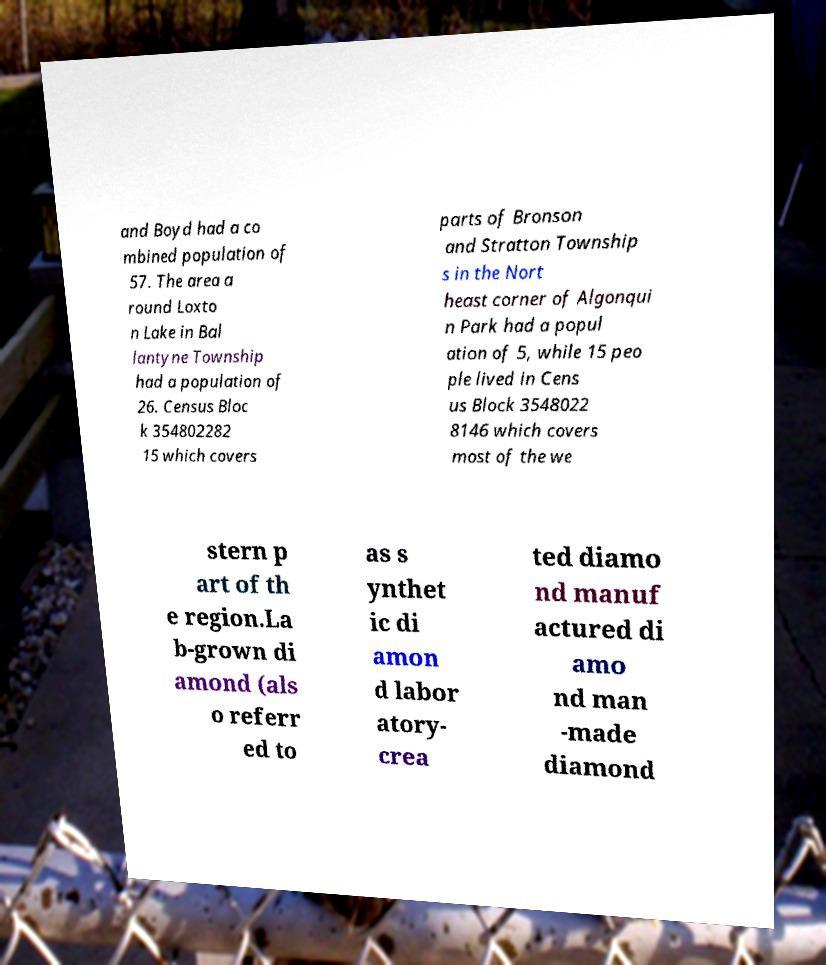Please identify and transcribe the text found in this image. and Boyd had a co mbined population of 57. The area a round Loxto n Lake in Bal lantyne Township had a population of 26. Census Bloc k 354802282 15 which covers parts of Bronson and Stratton Township s in the Nort heast corner of Algonqui n Park had a popul ation of 5, while 15 peo ple lived in Cens us Block 3548022 8146 which covers most of the we stern p art of th e region.La b-grown di amond (als o referr ed to as s ynthet ic di amon d labor atory- crea ted diamo nd manuf actured di amo nd man -made diamond 